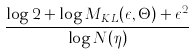Convert formula to latex. <formula><loc_0><loc_0><loc_500><loc_500>\frac { \log 2 + \log M _ { K L } ( \epsilon , \Theta ) + \epsilon ^ { 2 } } { \log N ( \eta ) }</formula> 